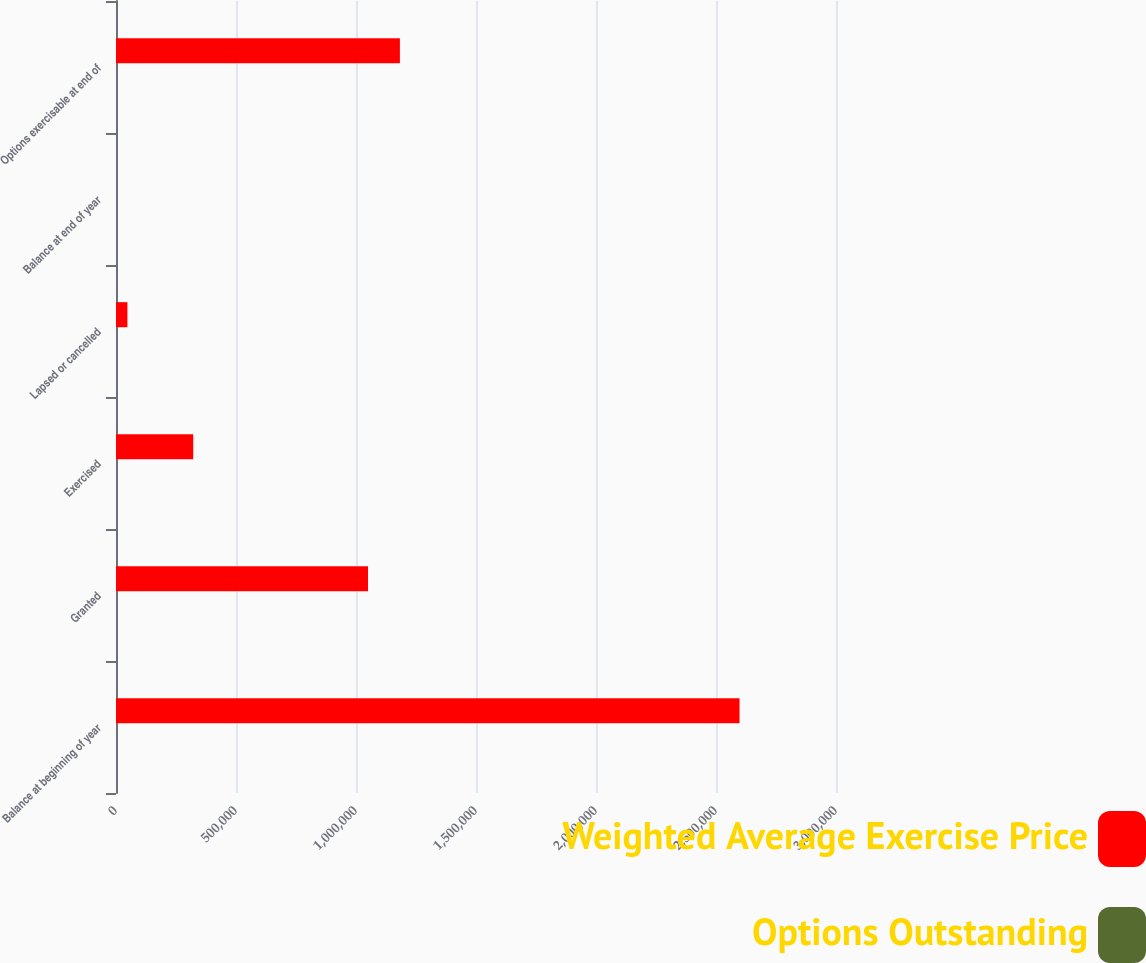Convert chart. <chart><loc_0><loc_0><loc_500><loc_500><stacked_bar_chart><ecel><fcel>Balance at beginning of year<fcel>Granted<fcel>Exercised<fcel>Lapsed or cancelled<fcel>Balance at end of year<fcel>Options exercisable at end of<nl><fcel>Weighted Average Exercise Price<fcel>2.59807e+06<fcel>1.05e+06<fcel>321846<fcel>47557<fcel>28.25<fcel>1.1829e+06<nl><fcel>Options Outstanding<fcel>23.76<fcel>28.25<fcel>20.64<fcel>23.32<fcel>25.49<fcel>22.62<nl></chart> 